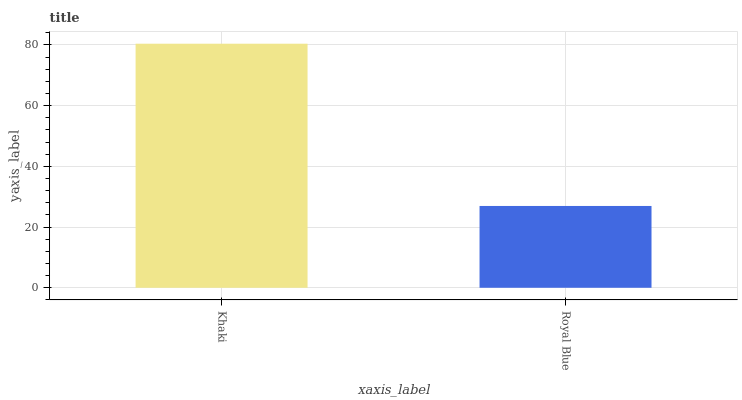Is Royal Blue the minimum?
Answer yes or no. Yes. Is Khaki the maximum?
Answer yes or no. Yes. Is Royal Blue the maximum?
Answer yes or no. No. Is Khaki greater than Royal Blue?
Answer yes or no. Yes. Is Royal Blue less than Khaki?
Answer yes or no. Yes. Is Royal Blue greater than Khaki?
Answer yes or no. No. Is Khaki less than Royal Blue?
Answer yes or no. No. Is Khaki the high median?
Answer yes or no. Yes. Is Royal Blue the low median?
Answer yes or no. Yes. Is Royal Blue the high median?
Answer yes or no. No. Is Khaki the low median?
Answer yes or no. No. 